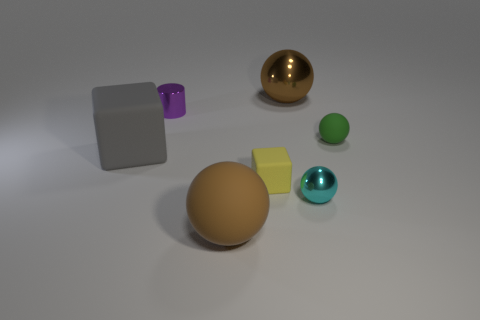Subtract all small metal spheres. How many spheres are left? 3 Subtract all green balls. How many balls are left? 3 Add 2 big yellow shiny blocks. How many objects exist? 9 Subtract all spheres. How many objects are left? 3 Subtract all red spheres. How many cyan cubes are left? 0 Subtract all gray matte things. Subtract all small green metal spheres. How many objects are left? 6 Add 5 large brown shiny things. How many large brown shiny things are left? 6 Add 3 tiny cyan shiny things. How many tiny cyan shiny things exist? 4 Subtract 0 cyan blocks. How many objects are left? 7 Subtract 3 spheres. How many spheres are left? 1 